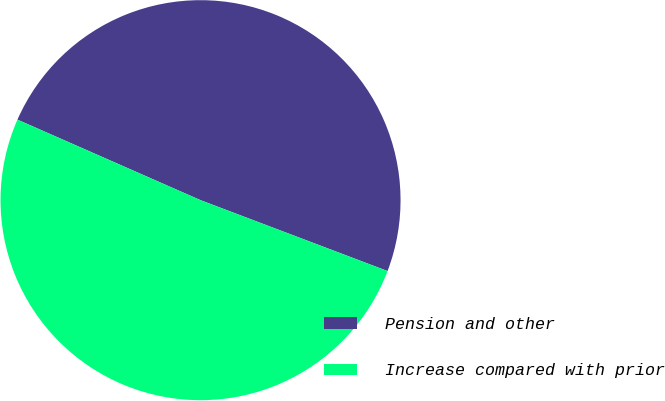Convert chart to OTSL. <chart><loc_0><loc_0><loc_500><loc_500><pie_chart><fcel>Pension and other<fcel>Increase compared with prior<nl><fcel>49.17%<fcel>50.83%<nl></chart> 